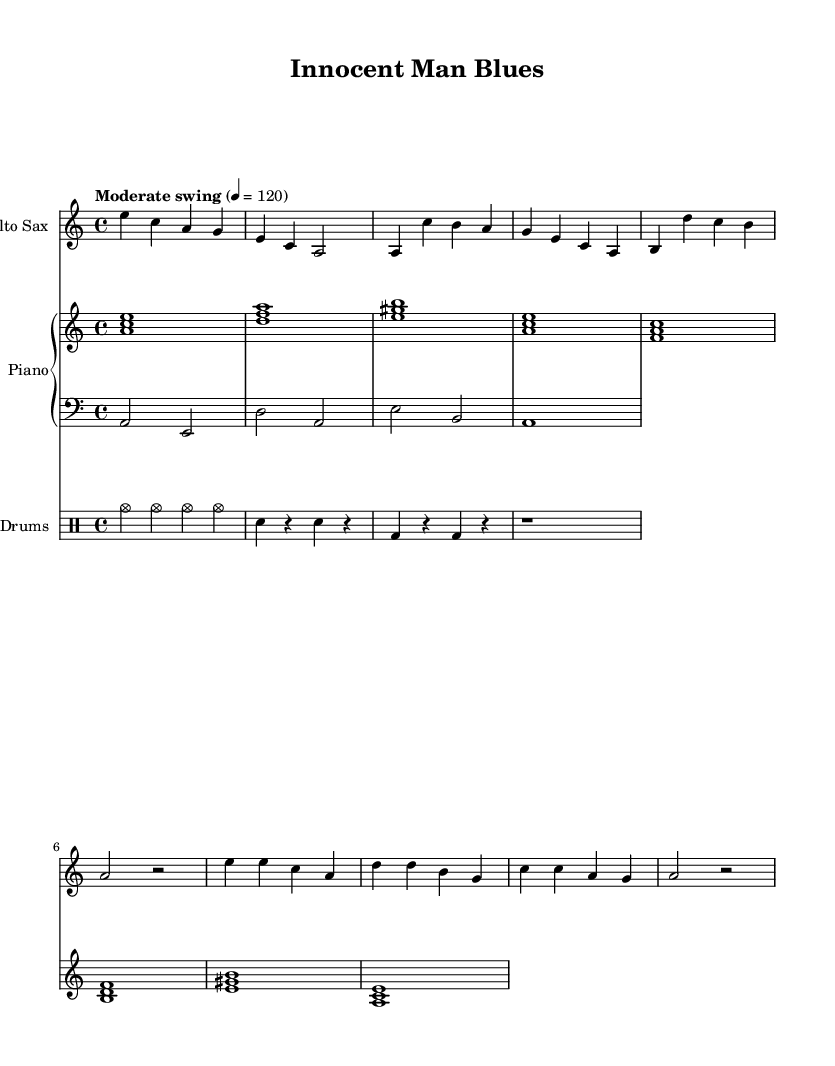What is the key signature of this music? The key signature is A minor, which has no sharps or flats.
Answer: A minor What is the time signature of this composition? The time signature is 4/4, meaning four beats per measure.
Answer: 4/4 What is the tempo marking for this piece? The tempo marking indicates a moderate swing at a quarter note equals 120 beats per minute.
Answer: Moderate swing How many measures are there in the alto sax part? The alto sax part consists of eight measures, as indicated by the notation.
Answer: Eight measures Which instrument plays the chord progression in this composition? The piano part plays the chord progression, as seen in the written chords above the staff.
Answer: Piano What is a characteristic feature of the drums in this jazz composition? The drums feature a consistent cymbal pattern with variations in the snare and bass drum.
Answer: Consistent cymbal pattern What is the overall mood conveyed by the title "Innocent Man Blues"? The title suggests a reflective and perhaps melancholic mood, typical of blues music that often addresses themes of injustice.
Answer: Reflective and melancholic 